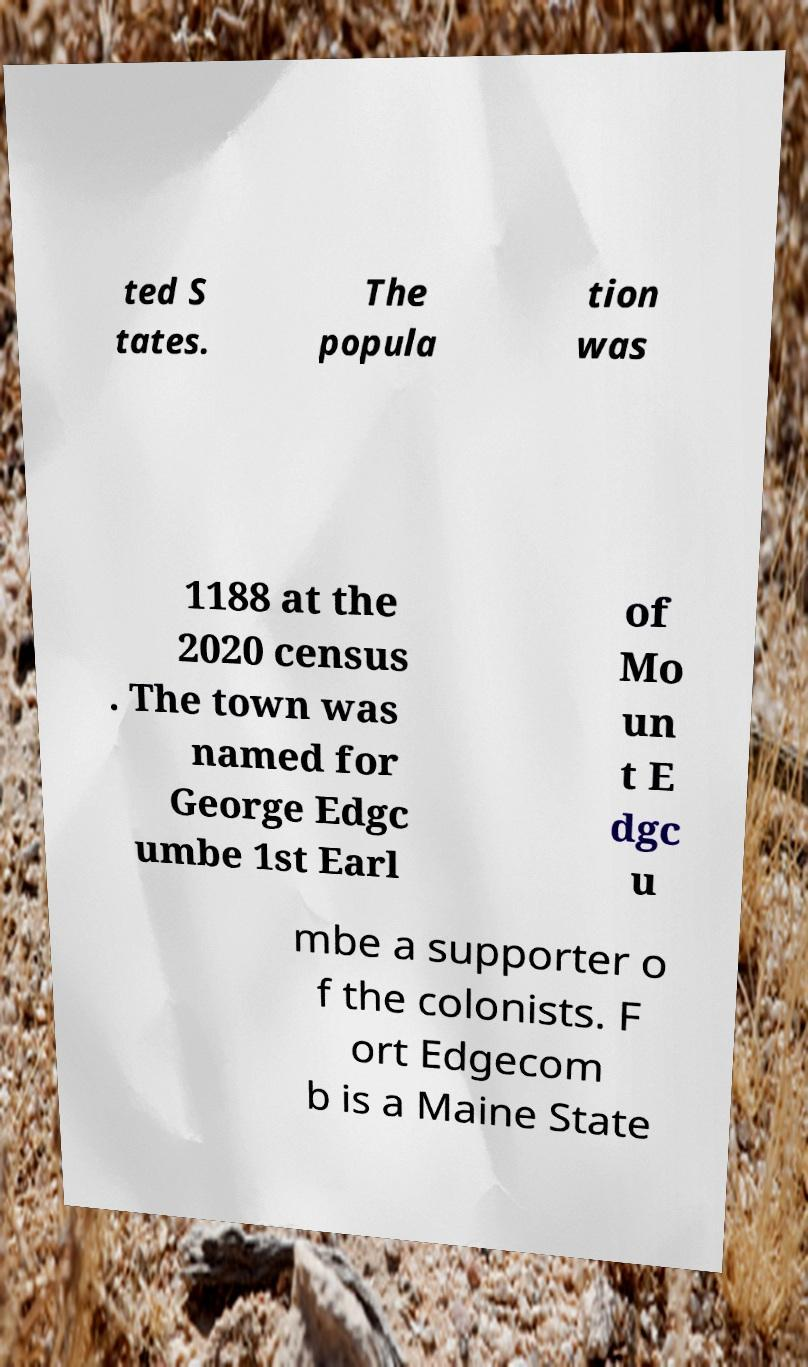Can you read and provide the text displayed in the image?This photo seems to have some interesting text. Can you extract and type it out for me? ted S tates. The popula tion was 1188 at the 2020 census . The town was named for George Edgc umbe 1st Earl of Mo un t E dgc u mbe a supporter o f the colonists. F ort Edgecom b is a Maine State 